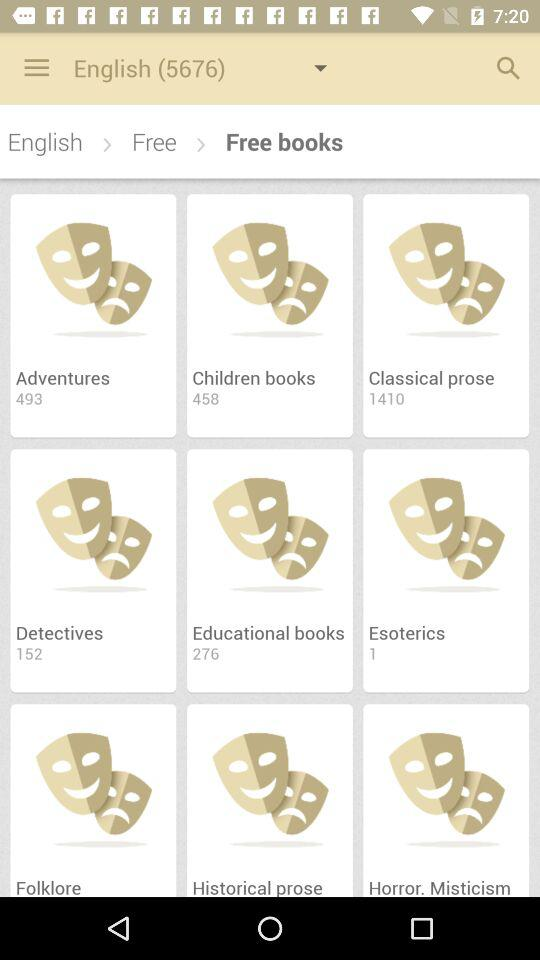What applications can I use to log in? You can use "Google+", "Facebook" and "Microsoft Windows" to log in. 